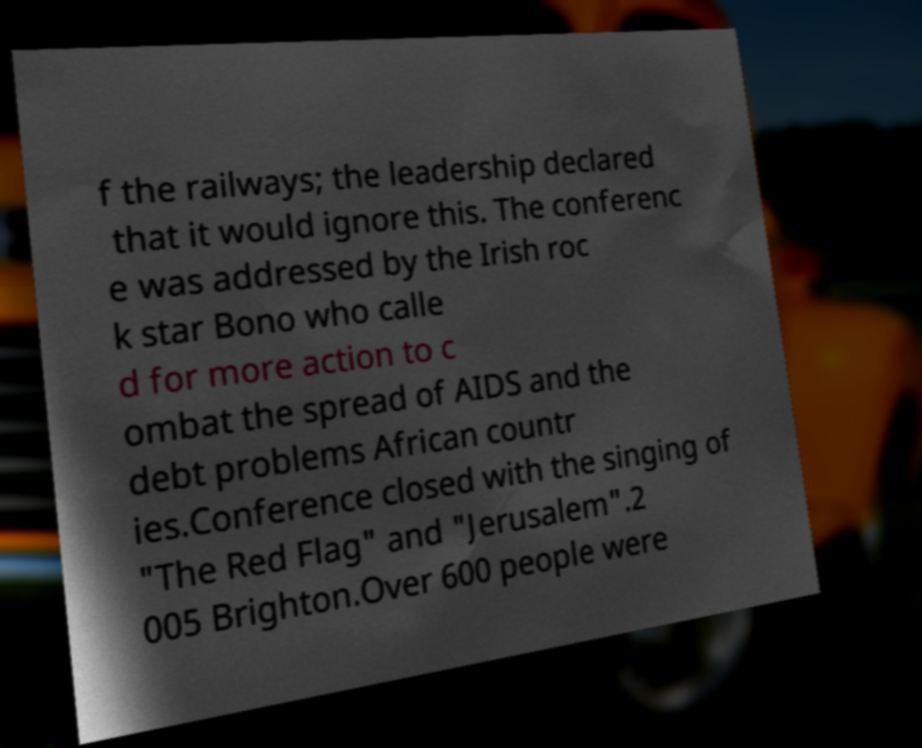Can you accurately transcribe the text from the provided image for me? f the railways; the leadership declared that it would ignore this. The conferenc e was addressed by the Irish roc k star Bono who calle d for more action to c ombat the spread of AIDS and the debt problems African countr ies.Conference closed with the singing of "The Red Flag" and "Jerusalem".2 005 Brighton.Over 600 people were 